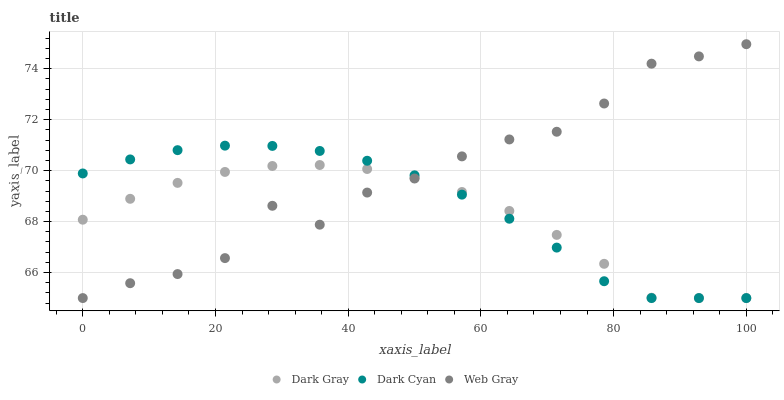Does Dark Gray have the minimum area under the curve?
Answer yes or no. Yes. Does Web Gray have the maximum area under the curve?
Answer yes or no. Yes. Does Dark Cyan have the minimum area under the curve?
Answer yes or no. No. Does Dark Cyan have the maximum area under the curve?
Answer yes or no. No. Is Dark Cyan the smoothest?
Answer yes or no. Yes. Is Web Gray the roughest?
Answer yes or no. Yes. Is Web Gray the smoothest?
Answer yes or no. No. Is Dark Cyan the roughest?
Answer yes or no. No. Does Dark Gray have the lowest value?
Answer yes or no. Yes. Does Web Gray have the highest value?
Answer yes or no. Yes. Does Dark Cyan have the highest value?
Answer yes or no. No. Does Dark Gray intersect Web Gray?
Answer yes or no. Yes. Is Dark Gray less than Web Gray?
Answer yes or no. No. Is Dark Gray greater than Web Gray?
Answer yes or no. No. 